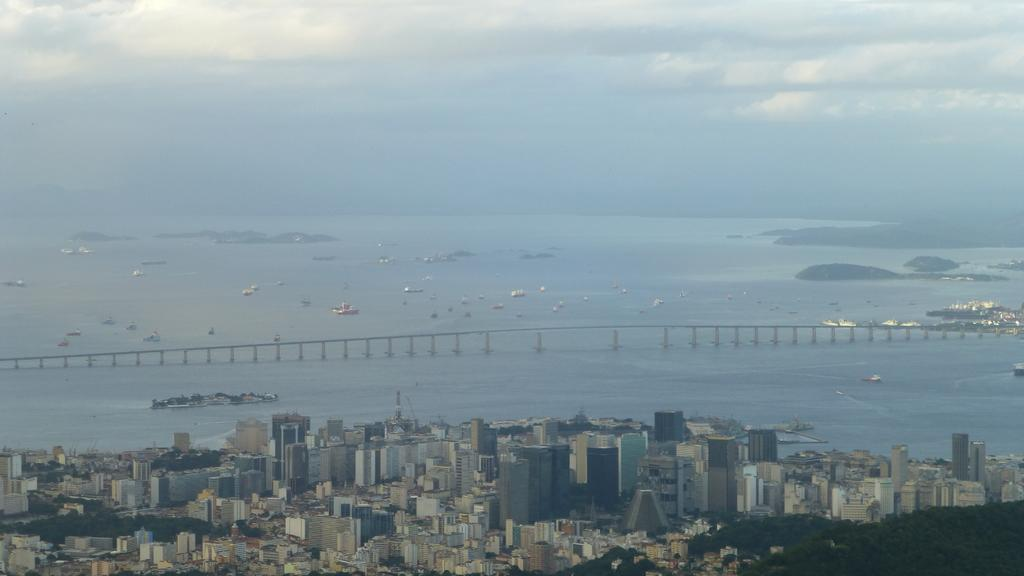What type of view is depicted in the image? The image is an aerial view. What structures can be seen in the image? There are buildings and a bridge visible in the image. What type of vegetation is present in the image? There are trees in the image. What body of water is visible in the image? There is water visible in the image, and ships are floating on it. What is visible in the background of the image? The sky is visible in the background of the image, and clouds are present. What type of band is playing in the image? There is no band present in the image. How many geese are flying over the water in the image? There are no geese visible in the image. 